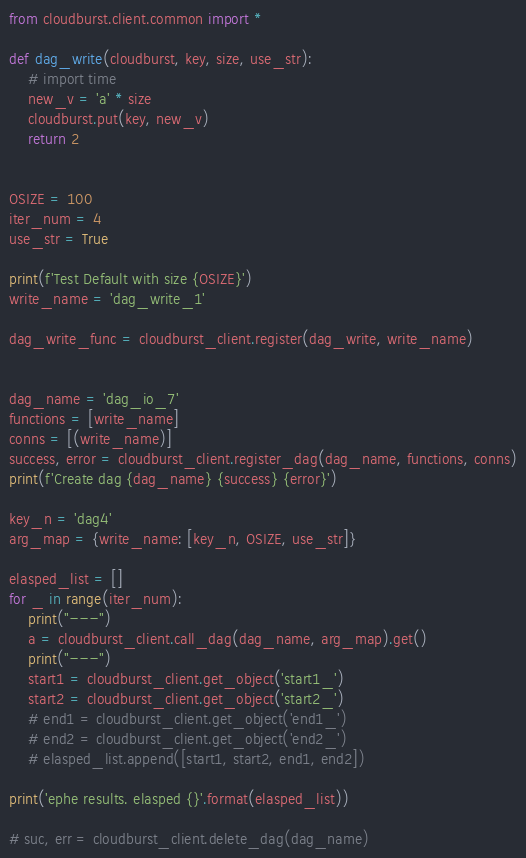Convert code to text. <code><loc_0><loc_0><loc_500><loc_500><_Python_>from cloudburst.client.common import *

def dag_write(cloudburst, key, size, use_str):
    # import time
    new_v = 'a' * size
    cloudburst.put(key, new_v)
    return 2


OSIZE = 100
iter_num = 4
use_str = True

print(f'Test Default with size {OSIZE}')
write_name = 'dag_write_1'

dag_write_func = cloudburst_client.register(dag_write, write_name)


dag_name = 'dag_io_7'
functions = [write_name]
conns = [(write_name)]
success, error = cloudburst_client.register_dag(dag_name, functions, conns)
print(f'Create dag {dag_name} {success} {error}')

key_n = 'dag4'
arg_map = {write_name: [key_n, OSIZE, use_str]}

elasped_list = []
for _ in range(iter_num):
    print("---")
    a = cloudburst_client.call_dag(dag_name, arg_map).get()
    print("---")
    start1 = cloudburst_client.get_object('start1_')
    start2 = cloudburst_client.get_object('start2_')
    # end1 = cloudburst_client.get_object('end1_')
    # end2 = cloudburst_client.get_object('end2_')
    # elasped_list.append([start1, start2, end1, end2])

print('ephe results. elasped {}'.format(elasped_list))

# suc, err = cloudburst_client.delete_dag(dag_name)</code> 